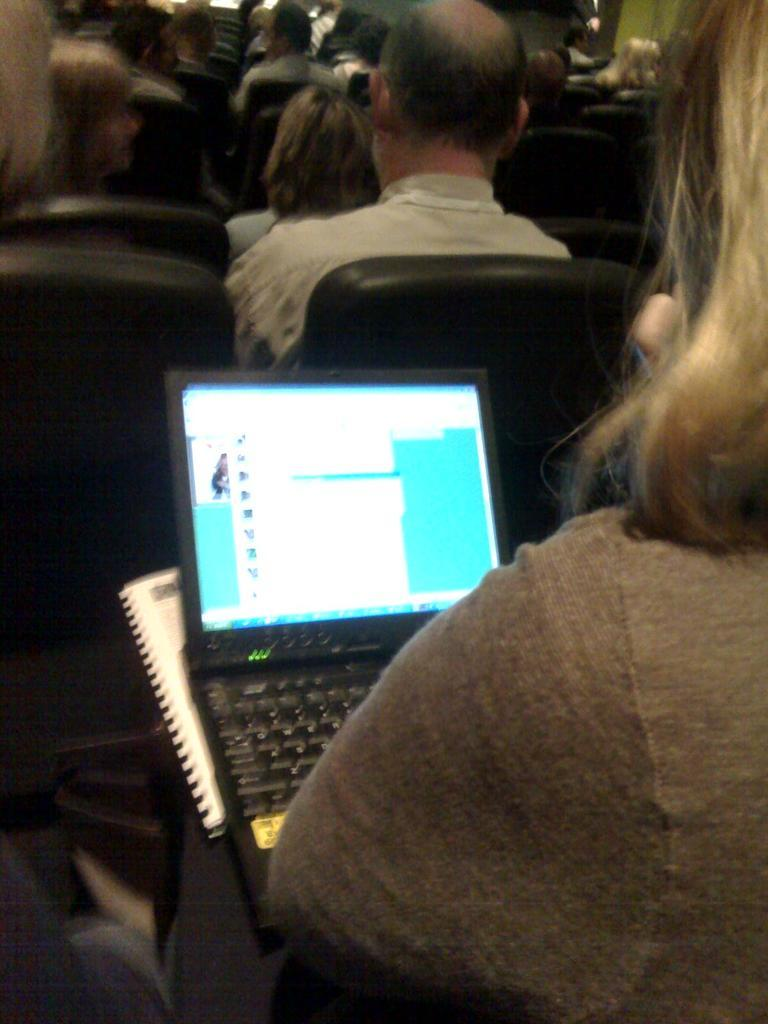What electronic device is visible in the image? There is a laptop in the image. What else is the person holding in the image? The person is also holding a book in the image. Can you describe the person's actions in the image? The person is holding the laptop and book. What can be seen in the background of the image? There is a group of people sitting in chairs in the background of the image. What type of patch is sewn onto the person's shirt in the image? There is no patch visible on the person's shirt in the image. What is the coach's opinion on the person's performance in the image? There is no coach or performance mentioned in the image, so it's not possible to determine the coach's opinion. 